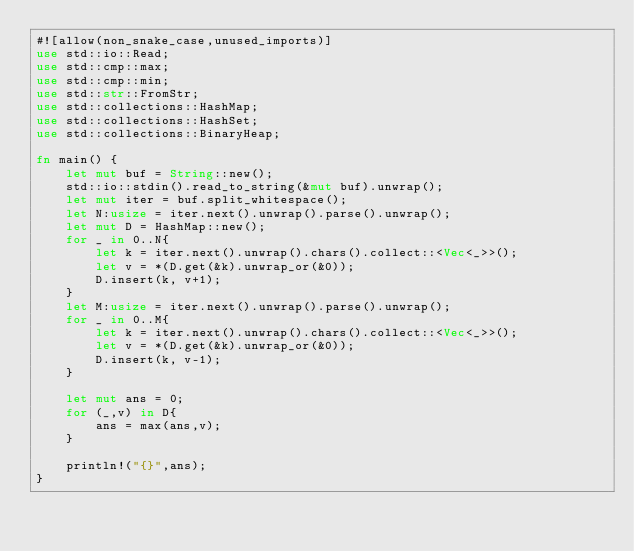<code> <loc_0><loc_0><loc_500><loc_500><_Rust_>#![allow(non_snake_case,unused_imports)]
use std::io::Read;
use std::cmp::max;
use std::cmp::min;
use std::str::FromStr;
use std::collections::HashMap;
use std::collections::HashSet;
use std::collections::BinaryHeap;

fn main() {
    let mut buf = String::new();
    std::io::stdin().read_to_string(&mut buf).unwrap();
    let mut iter = buf.split_whitespace();
    let N:usize = iter.next().unwrap().parse().unwrap();
    let mut D = HashMap::new();
    for _ in 0..N{
        let k = iter.next().unwrap().chars().collect::<Vec<_>>();
        let v = *(D.get(&k).unwrap_or(&0));
        D.insert(k, v+1);
    }
    let M:usize = iter.next().unwrap().parse().unwrap();
    for _ in 0..M{
        let k = iter.next().unwrap().chars().collect::<Vec<_>>();
        let v = *(D.get(&k).unwrap_or(&0));
        D.insert(k, v-1);
    }

    let mut ans = 0;
    for (_,v) in D{
        ans = max(ans,v);
    }

    println!("{}",ans);
}</code> 